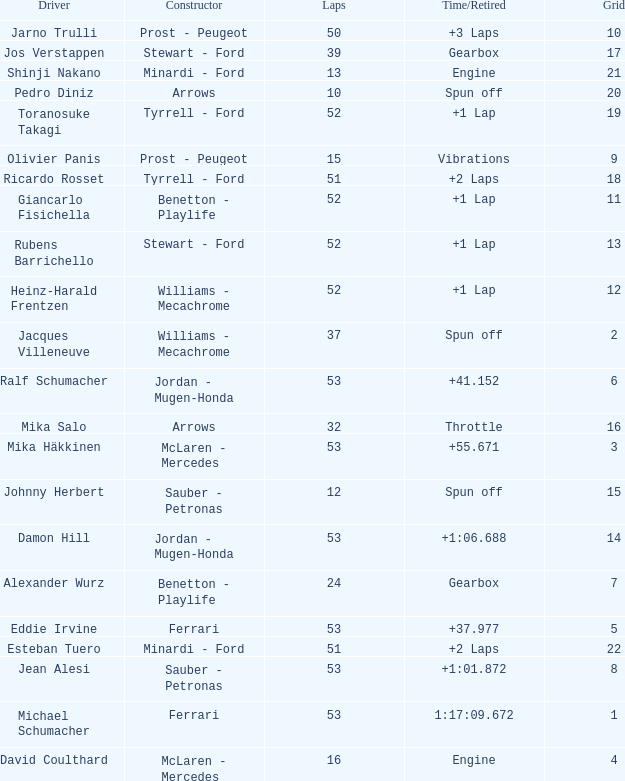What is the grid total for ralf schumacher racing over 53 laps? None. 